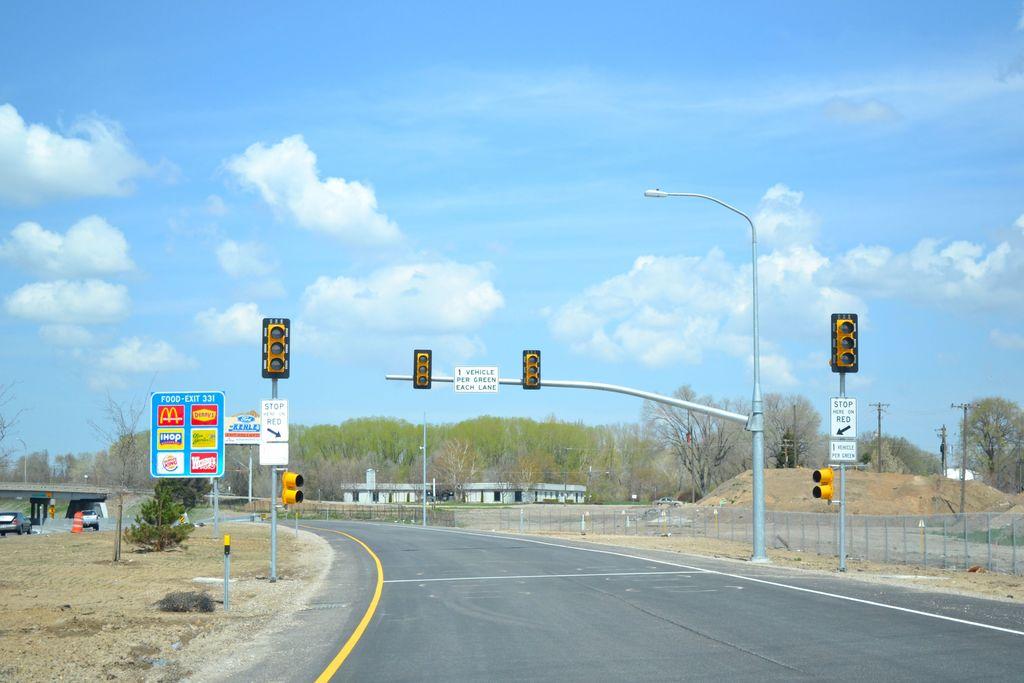What are these signs telling us?
Give a very brief answer. Stop here on red. What is the exit number?
Provide a short and direct response. 331. 